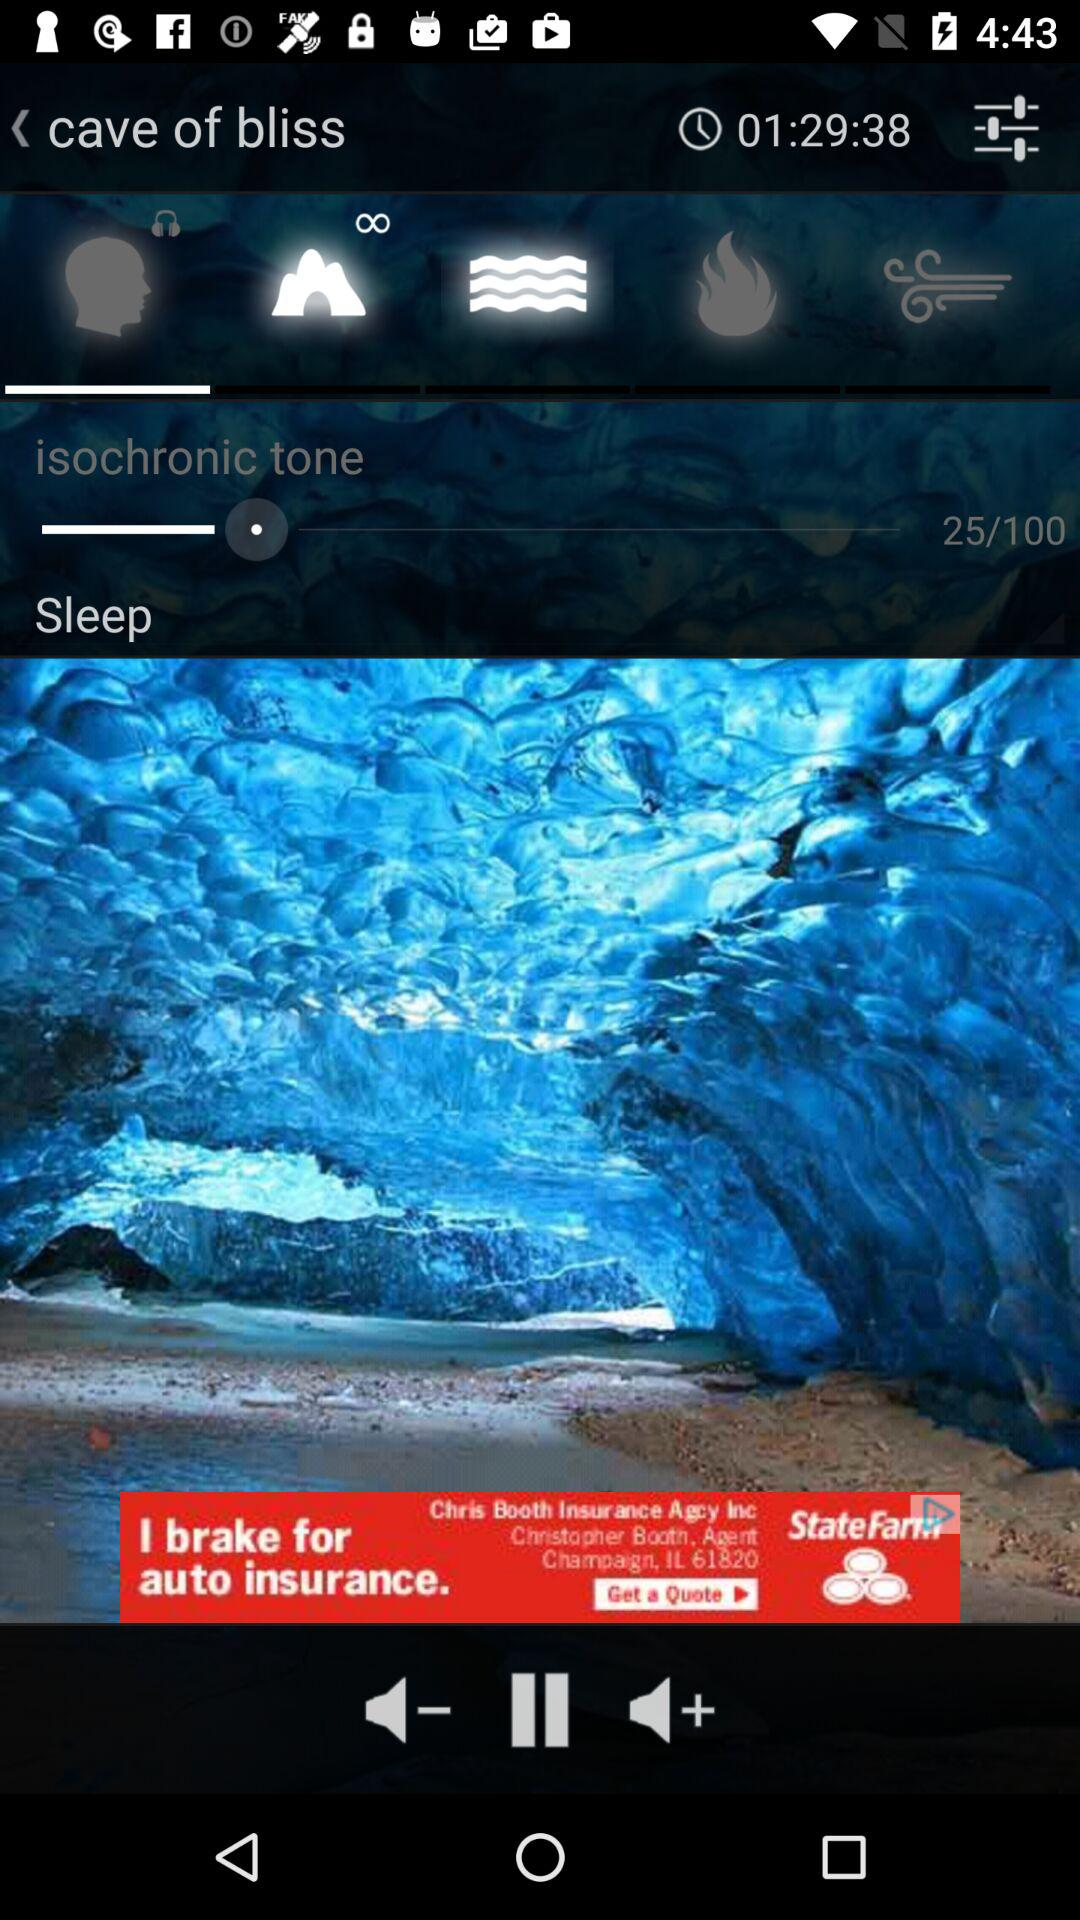At what level of isochronic tone are we now? You are at level 25 of isochronic tone. 